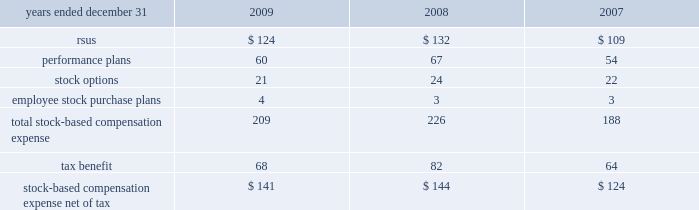14 .
Stock compensation plans the table summarizes stock-based compensation expense recognized in continuing operations in the consolidated statements of income in compensation and benefits ( in millions ) : .
During 2009 , the company converted its stock administration system to a new service provider .
In connection with this conversion , a reconciliation of the methodologies and estimates utilized was performed , which resulted in a $ 12 million reduction of expense for the year ended december 31 , 2009 .
Stock awards stock awards , in the form of rsus , are granted to certain employees and consist of both performance-based and service-based rsus .
Service-based awards generally vest between three and ten years from the date of grant .
The fair value of service-based awards is based upon the market price of the underlying common stock at the date of grant .
With certain limited exceptions , any break in continuous employment will cause the forfeiture of all unvested awards .
Compensation expense associated with stock awards is recognized over the service period using the straight-line method .
Dividend equivalents are paid on certain service-based rsus , based on the initial grant amount .
At december 31 , 2009 , 2008 and 2007 , the number of shares available for stock awards is included with options available for grant .
Performance-based rsus have been granted to certain employees .
Vesting of these awards is contingent upon meeting various individual , divisional or company-wide performance conditions , including revenue generation or growth in revenue , pretax income or earnings per share over a one- to five-year period .
The performance conditions are not considered in the determination of the grant date fair value for these awards .
The fair value of performance-based awards is based upon the market price of the underlying common stock at the date of grant .
Compensation expense is recognized over the performance period , and in certain cases an additional vesting period , based on management 2019s estimate of the number of units expected to vest .
Compensation expense is adjusted to reflect the actual number of shares paid out at the end of the programs .
The payout of shares under these performance-based plans may range from 0-200% ( 0-200 % ) of the number of units granted , based on the plan .
Dividend equivalents are generally not paid on the performance-based rsus .
During 2009 , the company granted approximately 2 million shares in connection with the completion of the 2006 leadership performance plan ( 2018 2018lpp 2019 2019 ) cycle .
During 2009 , 2008 and 2007 , the company granted approximately 3.7 million , 4.2 million and 4.3 million restricted shares , respectively , in connection with the company 2019s incentive compensation plans. .
What was the change in the stock compensation plans rsu in millions from 2007 to 2008? 
Computations: (132 - 109)
Answer: 23.0. 14 .
Stock compensation plans the table summarizes stock-based compensation expense recognized in continuing operations in the consolidated statements of income in compensation and benefits ( in millions ) : .
During 2009 , the company converted its stock administration system to a new service provider .
In connection with this conversion , a reconciliation of the methodologies and estimates utilized was performed , which resulted in a $ 12 million reduction of expense for the year ended december 31 , 2009 .
Stock awards stock awards , in the form of rsus , are granted to certain employees and consist of both performance-based and service-based rsus .
Service-based awards generally vest between three and ten years from the date of grant .
The fair value of service-based awards is based upon the market price of the underlying common stock at the date of grant .
With certain limited exceptions , any break in continuous employment will cause the forfeiture of all unvested awards .
Compensation expense associated with stock awards is recognized over the service period using the straight-line method .
Dividend equivalents are paid on certain service-based rsus , based on the initial grant amount .
At december 31 , 2009 , 2008 and 2007 , the number of shares available for stock awards is included with options available for grant .
Performance-based rsus have been granted to certain employees .
Vesting of these awards is contingent upon meeting various individual , divisional or company-wide performance conditions , including revenue generation or growth in revenue , pretax income or earnings per share over a one- to five-year period .
The performance conditions are not considered in the determination of the grant date fair value for these awards .
The fair value of performance-based awards is based upon the market price of the underlying common stock at the date of grant .
Compensation expense is recognized over the performance period , and in certain cases an additional vesting period , based on management 2019s estimate of the number of units expected to vest .
Compensation expense is adjusted to reflect the actual number of shares paid out at the end of the programs .
The payout of shares under these performance-based plans may range from 0-200% ( 0-200 % ) of the number of units granted , based on the plan .
Dividend equivalents are generally not paid on the performance-based rsus .
During 2009 , the company granted approximately 2 million shares in connection with the completion of the 2006 leadership performance plan ( 2018 2018lpp 2019 2019 ) cycle .
During 2009 , 2008 and 2007 , the company granted approximately 3.7 million , 4.2 million and 4.3 million restricted shares , respectively , in connection with the company 2019s incentive compensation plans. .
What is the average tax benefit , in millions? 
Rationale: it is the sum of all tax benefits divided by three .
Computations: table_average(tax benefit, none)
Answer: 71.33333. 